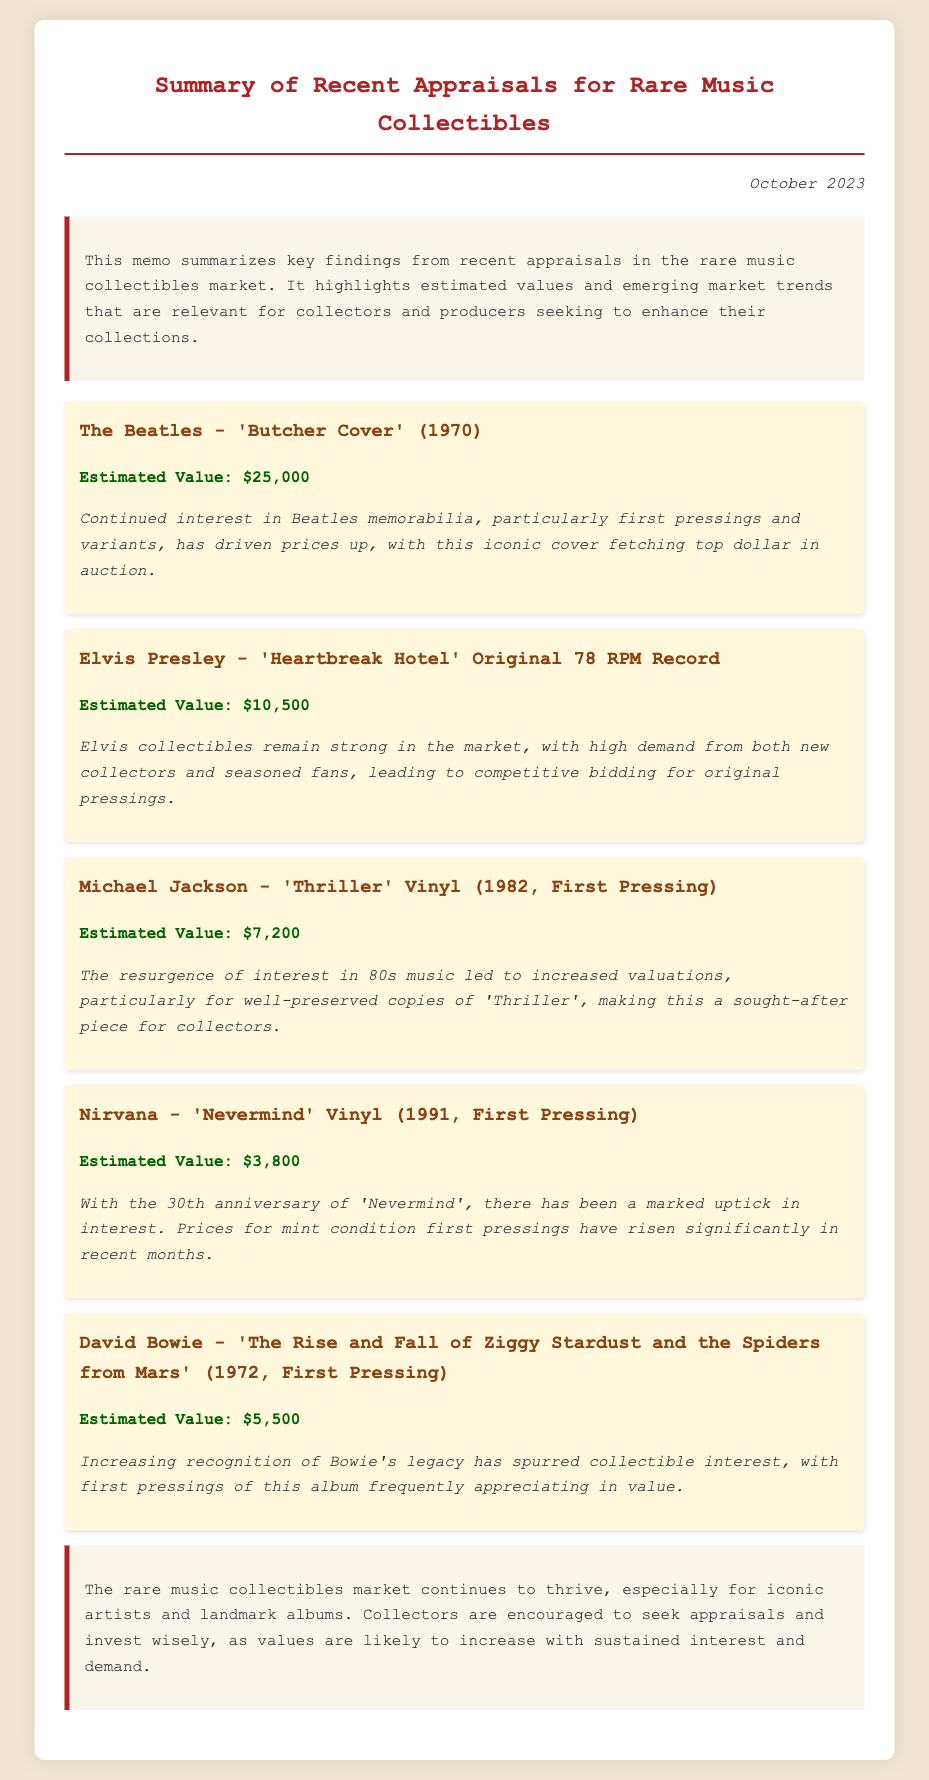What is the estimated value of The Beatles' 'Butcher Cover'? The estimated value is clearly stated in the appraisal section for The Beatles' 'Butcher Cover'.
Answer: $25,000 What year was Michael Jackson's 'Thriller' first pressed? The year of the first pressing for Michael Jackson's 'Thriller' is mentioned in the appraisal details.
Answer: 1982 Which artist's collectible remains strong in the market? The memo highlights an ongoing strength in the market for Elvis collectibles.
Answer: Elvis Presley What is the estimated value of Nirvana's 'Nevermind'? The estimated value is given in the specific appraisal for Nirvana's 'Nevermind'.
Answer: $3,800 What trend is noted for David Bowie's first pressing of 'Ziggy Stardust'? The trend highlights an increasing recognition of Bowie's legacy impacting collectible interest.
Answer: Appreciation in value How does demand for 80s music affect the value of 'Thriller'? The memo states that there has been a resurgence of interest in 80s music impacting valuations.
Answer: Increased valuations Which iconic cover is fetching top dollar in auctions? The memo cites The Beatles' 'Butcher Cover' specifically as fetching top dollar.
Answer: Butcher Cover What is the conclusion regarding the rare music collectibles market? The conclusion summarizes the market's thriving nature and encourages appraisals.
Answer: Continues to thrive 